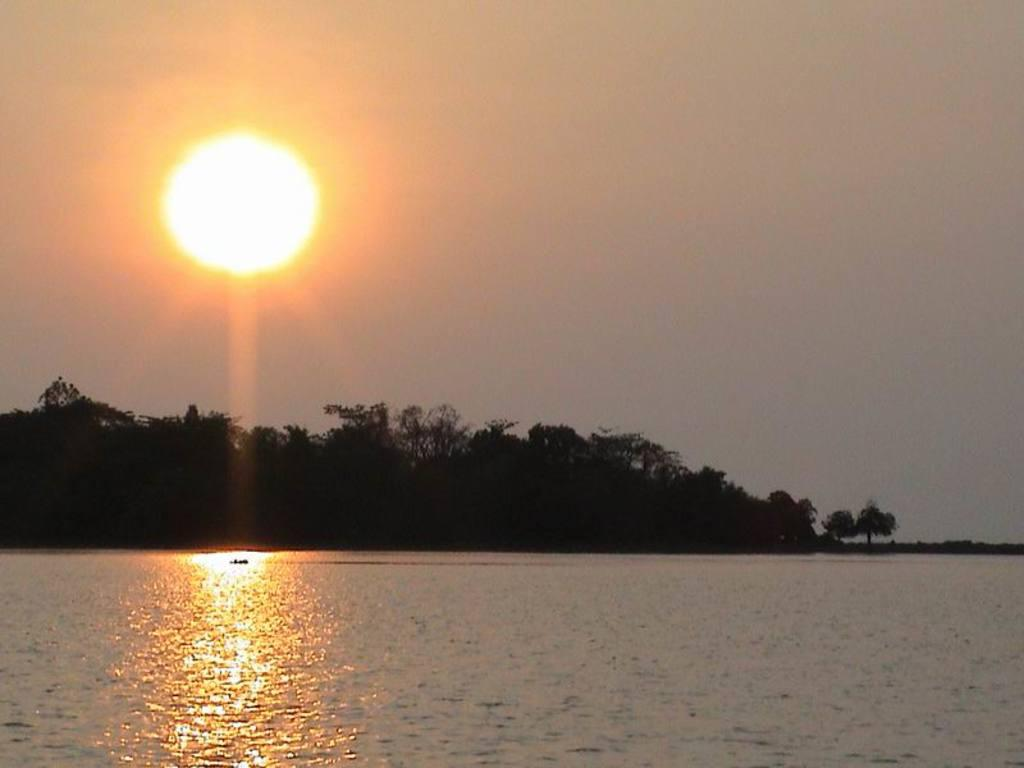What is at the bottom of the image? There is water at the bottom of the image. What might the water be part of? The water might be in a river. What type of natural environment can be seen in the background of the image? There are trees in the background of the image. What is visible at the top of the image? The sky is visible at the top of the image. What celestial body can be seen in the sky? The sun is present in the sky. What type of circle is being used to work on the system in the image? There is no circle or system present in the image; it features water, trees, and the sky. 